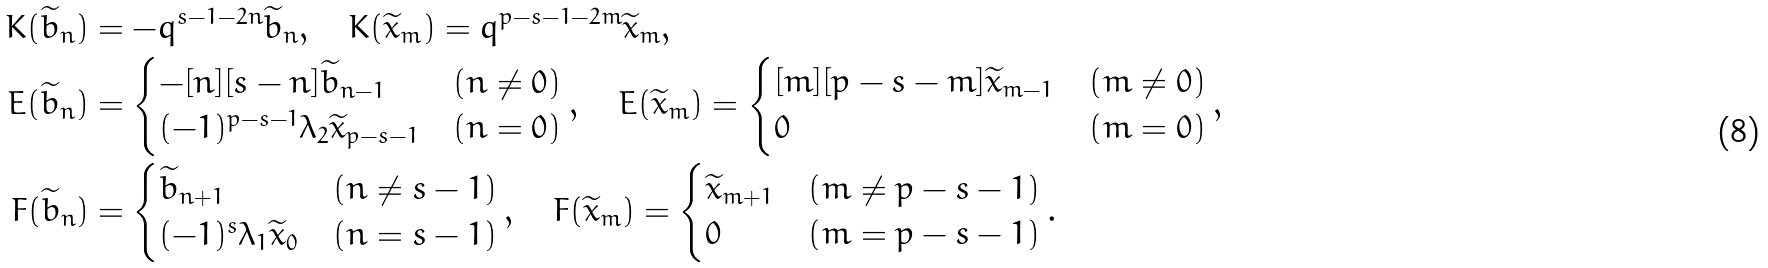<formula> <loc_0><loc_0><loc_500><loc_500>K ( \widetilde { b } _ { n } ) & = - q ^ { s - 1 - 2 n } \widetilde { b } _ { n } , \quad K ( \widetilde { x } _ { m } ) = q ^ { p - s - 1 - 2 m } \widetilde { x } _ { m } , \\ E ( \widetilde { b } _ { n } ) & = \begin{cases} - [ n ] [ s - n ] \widetilde { b } _ { n - 1 } & ( n \ne 0 ) \\ ( - 1 ) ^ { p - s - 1 } \lambda _ { 2 } \widetilde { x } _ { p - s - 1 } & ( n = 0 ) \end{cases} , \quad E ( \widetilde { x } _ { m } ) = \begin{cases} [ m ] [ p - s - m ] \widetilde { x } _ { m - 1 } & ( m \neq 0 ) \\ 0 & ( m = 0 ) \end{cases} , \\ F ( \widetilde { b } _ { n } ) & = \begin{cases} \widetilde { b } _ { n + 1 } & ( n \neq s - 1 ) \\ ( - 1 ) ^ { s } \lambda _ { 1 } \widetilde { x } _ { 0 } & ( n = s - 1 ) \end{cases} , \quad F ( \widetilde { x } _ { m } ) = \begin{cases} \widetilde { x } _ { m + 1 } & ( m \neq p - s - 1 ) \\ 0 & ( m = p - s - 1 ) \end{cases} .</formula> 